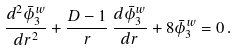<formula> <loc_0><loc_0><loc_500><loc_500>\frac { d ^ { 2 } \bar { \phi } _ { 3 } ^ { w } } { d r ^ { 2 } } + \frac { D - 1 } { r } \, \frac { d \bar { \phi } _ { 3 } ^ { w } } { d r } + 8 \bar { \phi } _ { 3 } ^ { w } = 0 \, .</formula> 